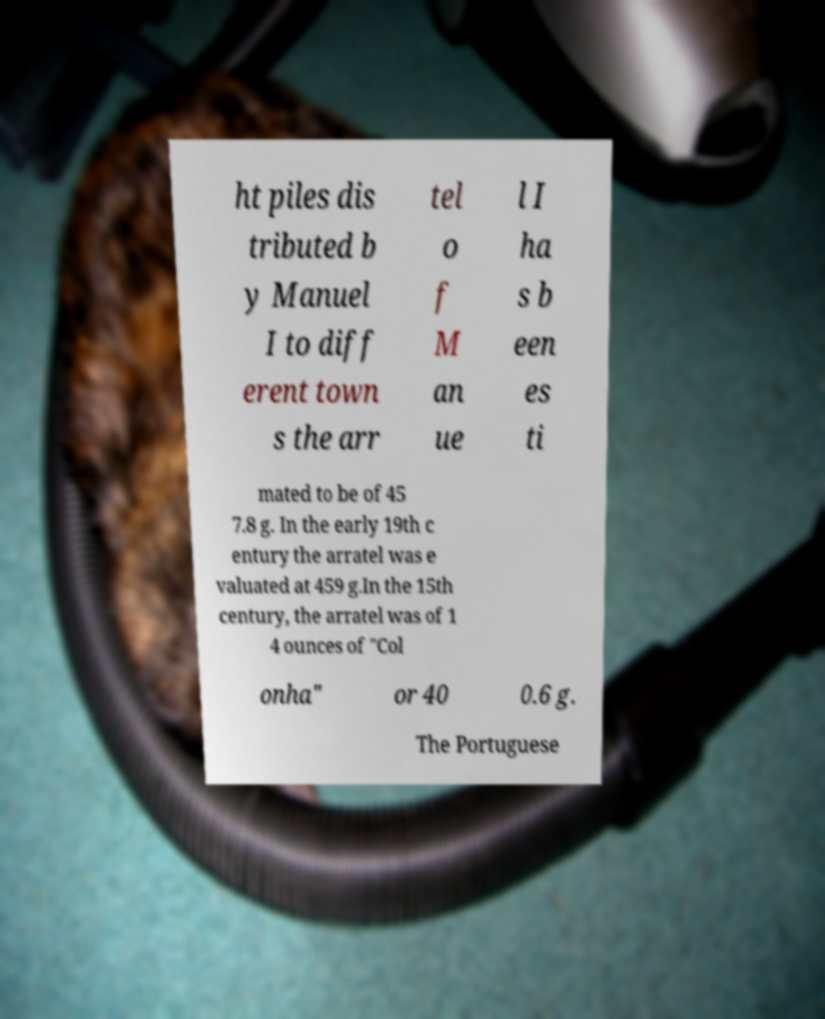Please read and relay the text visible in this image. What does it say? ht piles dis tributed b y Manuel I to diff erent town s the arr tel o f M an ue l I ha s b een es ti mated to be of 45 7.8 g. In the early 19th c entury the arratel was e valuated at 459 g.In the 15th century, the arratel was of 1 4 ounces of "Col onha" or 40 0.6 g. The Portuguese 